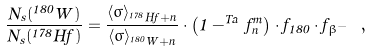<formula> <loc_0><loc_0><loc_500><loc_500>\frac { N _ { s } ( ^ { 1 8 0 } W ) } { N _ { s } ( ^ { 1 7 8 } H f ) } = \frac { \langle \sigma \rangle _ { ^ { 1 7 8 } H f + n } } { \langle \sigma \rangle _ { ^ { 1 8 0 } W + n } } \cdot \left ( 1 - ^ { T a } \, f ^ { m } _ { n } \right ) \cdot f _ { 1 8 0 } \cdot f _ { \beta ^ { - } } \ ,</formula> 